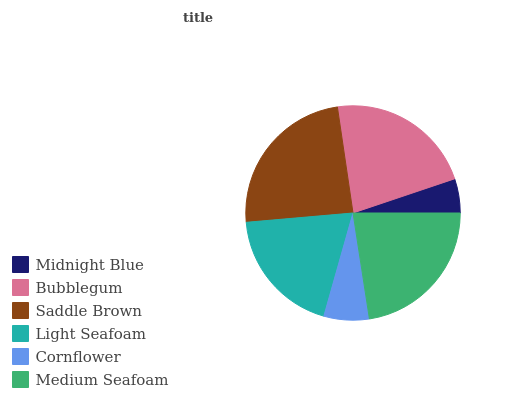Is Midnight Blue the minimum?
Answer yes or no. Yes. Is Saddle Brown the maximum?
Answer yes or no. Yes. Is Bubblegum the minimum?
Answer yes or no. No. Is Bubblegum the maximum?
Answer yes or no. No. Is Bubblegum greater than Midnight Blue?
Answer yes or no. Yes. Is Midnight Blue less than Bubblegum?
Answer yes or no. Yes. Is Midnight Blue greater than Bubblegum?
Answer yes or no. No. Is Bubblegum less than Midnight Blue?
Answer yes or no. No. Is Bubblegum the high median?
Answer yes or no. Yes. Is Light Seafoam the low median?
Answer yes or no. Yes. Is Cornflower the high median?
Answer yes or no. No. Is Bubblegum the low median?
Answer yes or no. No. 